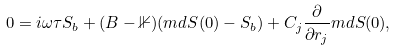Convert formula to latex. <formula><loc_0><loc_0><loc_500><loc_500>0 & = i \omega \tau S _ { b } + ( B - \mathbb { 1 } ) ( m d { S } ( 0 ) - S _ { b } ) + C _ { j } \frac { \partial } { \partial r _ { j } } m d { S } ( 0 ) ,</formula> 